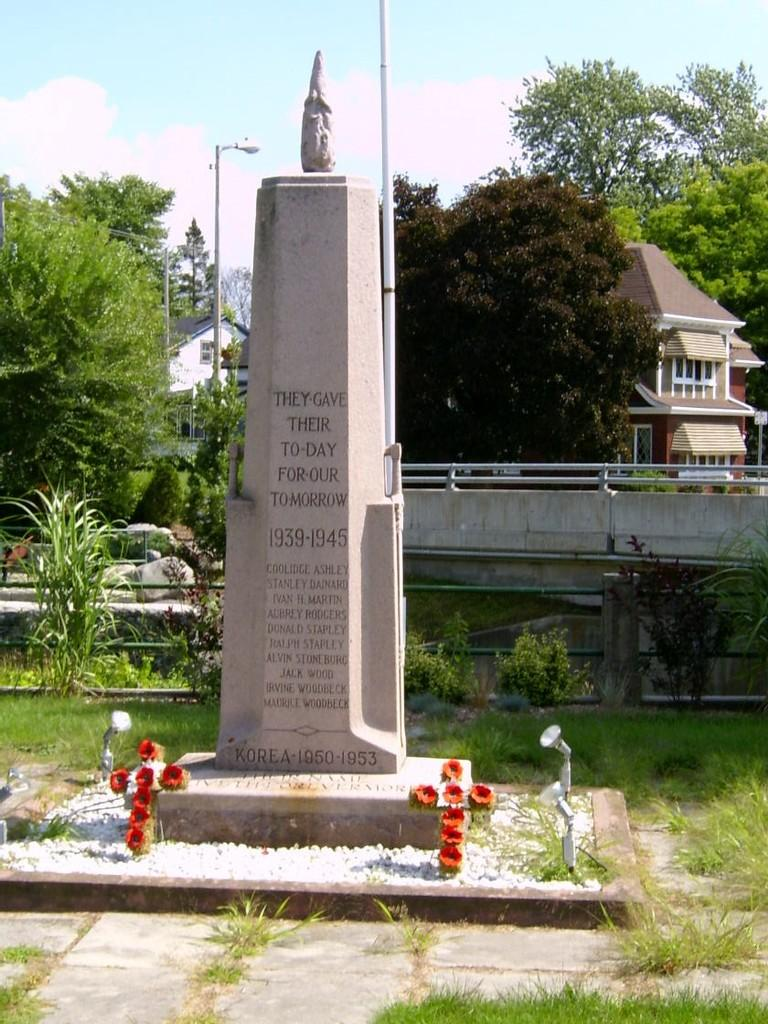What is the main subject of the image? There is a memorial in the image. What type of vegetation can be seen in the image? There is grass and trees in the image. Are there any decorative elements in the image? Yes, there are flowers in the image. What type of structure is present in the image? There is a fence in the image. What can be seen in the background of the image? The sky with clouds is visible in the background of the image. Are there any buildings visible in the image? Yes, there are buildings with windows in the image. What type of instrument is being played by the person standing next to the memorial in the image? There is no person or instrument present in the image; it only features a memorial, vegetation, and structures. 